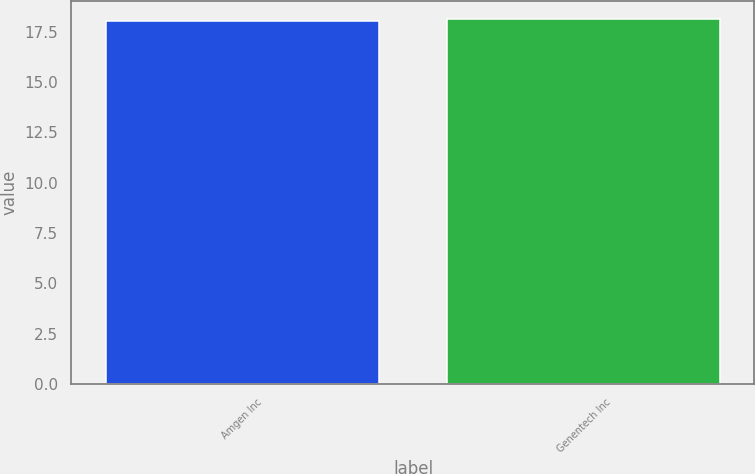<chart> <loc_0><loc_0><loc_500><loc_500><bar_chart><fcel>Amgen Inc<fcel>Genentech Inc<nl><fcel>18<fcel>18.1<nl></chart> 